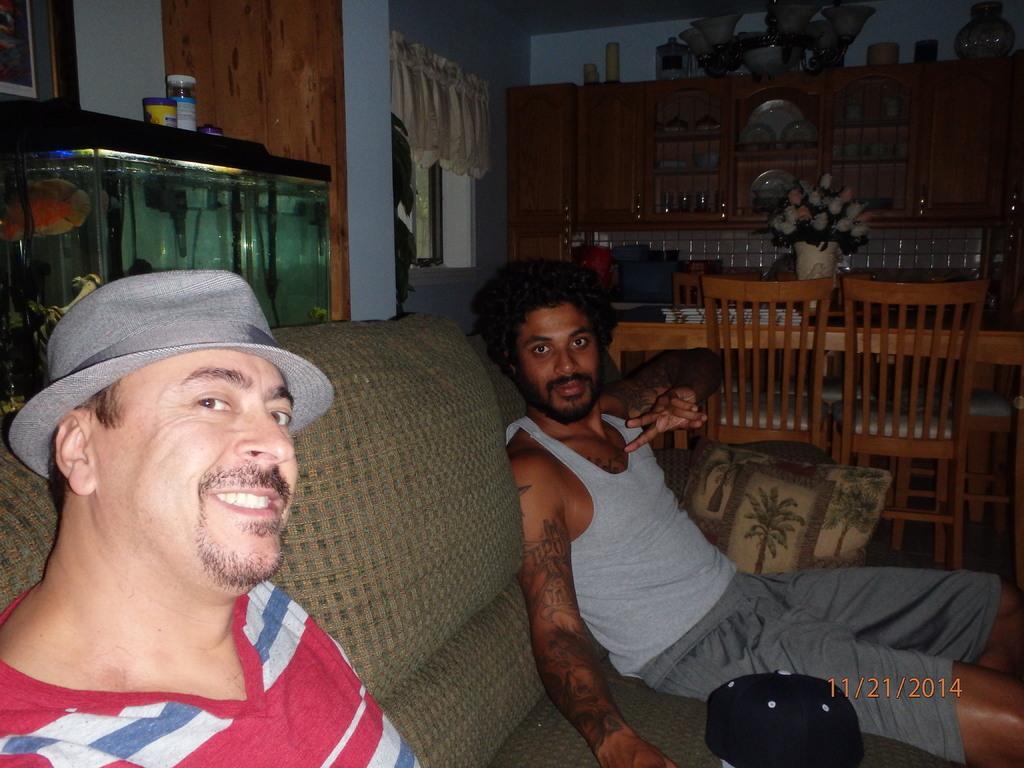Could you give a brief overview of what you see in this image? There are two persons sitting on the couch and at the left side of the image there is a fish aquarium and at the backside of the image there is a wooden color glass door and there is also a dining table at the background 